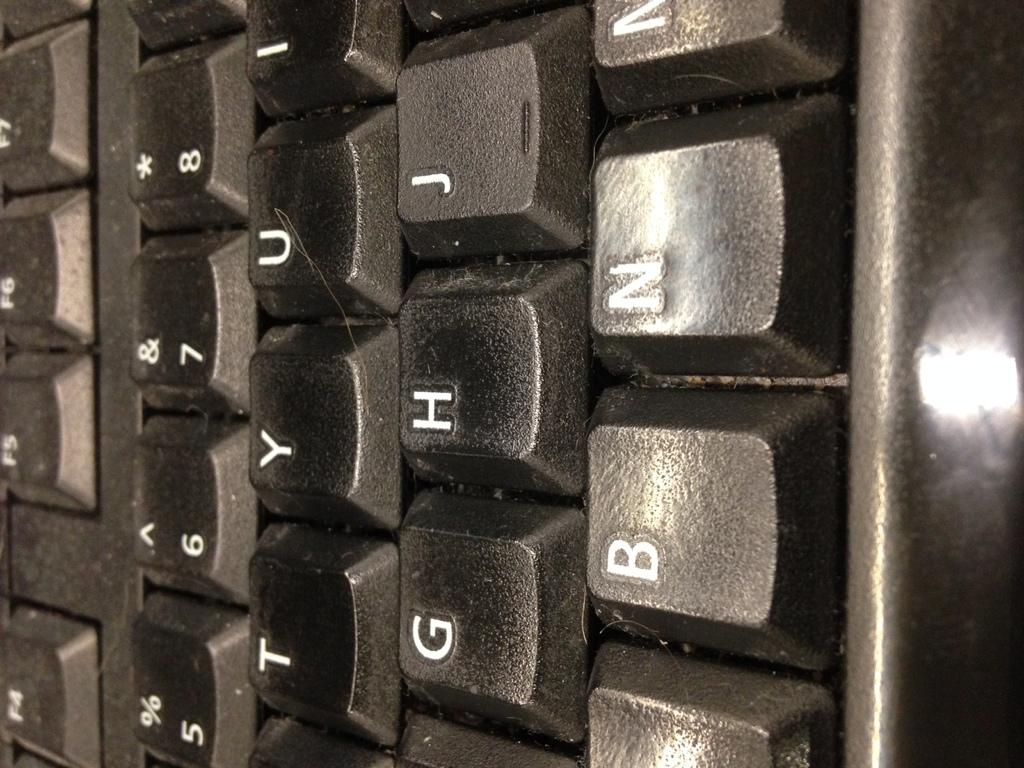What letter key is above b in this image?
Your answer should be compact. G. What number keys are shown?
Keep it short and to the point. 5, 6, 7, 8. 